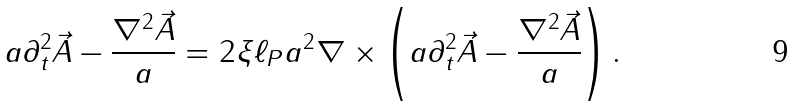<formula> <loc_0><loc_0><loc_500><loc_500>a \partial _ { t } ^ { 2 } \vec { A } - \frac { \nabla ^ { 2 } \vec { A } } { a } = 2 \xi \ell _ { P } a ^ { 2 } \nabla \times \left ( a \partial _ { t } ^ { 2 } \vec { A } - \frac { \nabla ^ { 2 } \vec { A } } { a } \right ) .</formula> 